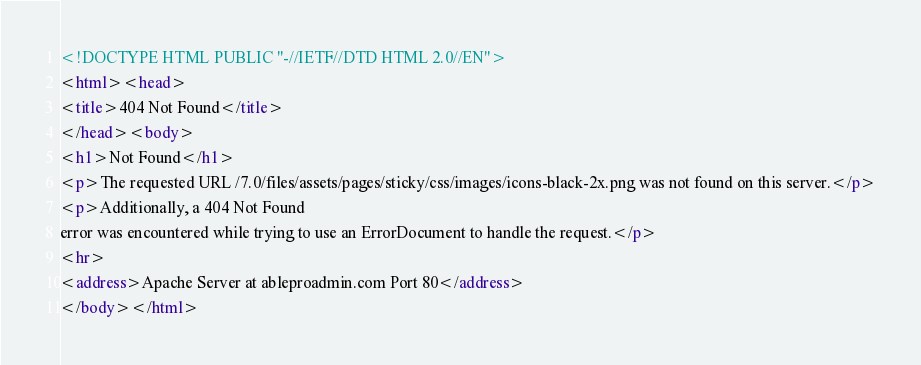<code> <loc_0><loc_0><loc_500><loc_500><_HTML_><!DOCTYPE HTML PUBLIC "-//IETF//DTD HTML 2.0//EN">
<html><head>
<title>404 Not Found</title>
</head><body>
<h1>Not Found</h1>
<p>The requested URL /7.0/files/assets/pages/sticky/css/images/icons-black-2x.png was not found on this server.</p>
<p>Additionally, a 404 Not Found
error was encountered while trying to use an ErrorDocument to handle the request.</p>
<hr>
<address>Apache Server at ableproadmin.com Port 80</address>
</body></html>
</code> 